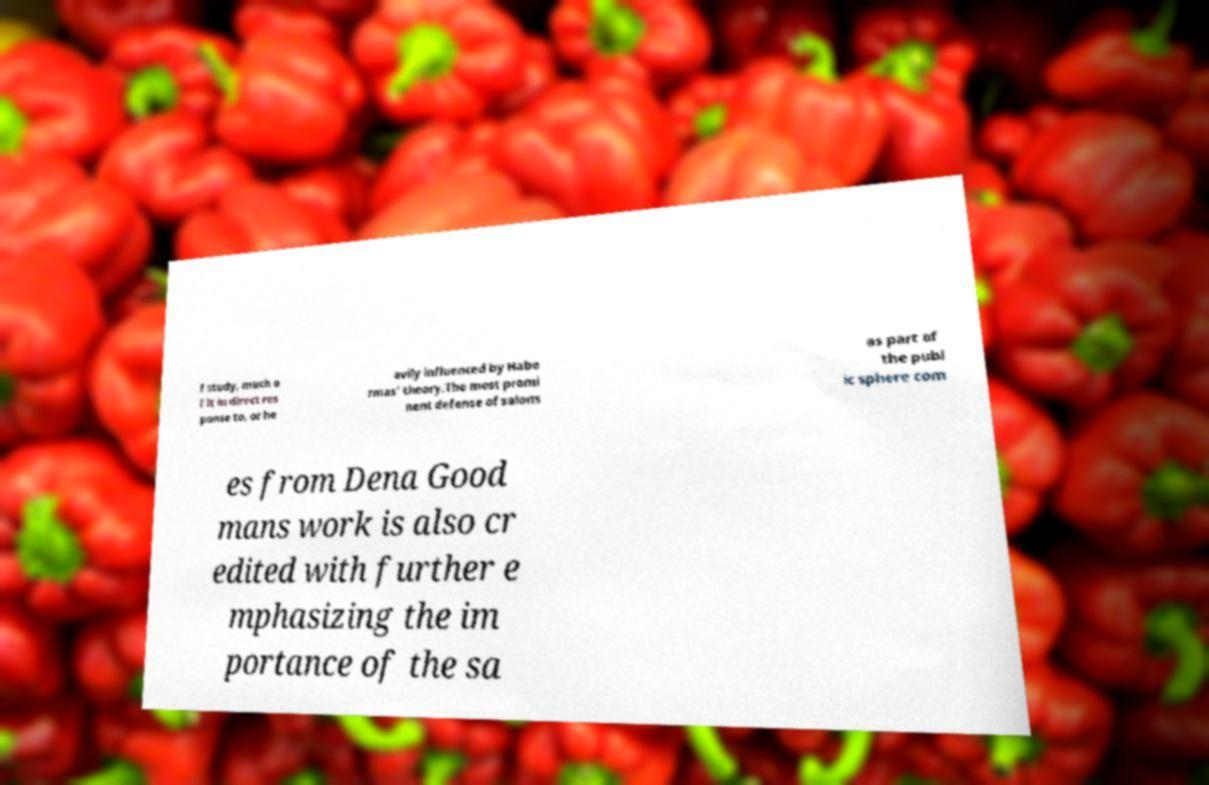Could you assist in decoding the text presented in this image and type it out clearly? f study, much o f it in direct res ponse to, or he avily influenced by Habe rmas' theory.The most promi nent defense of salons as part of the publ ic sphere com es from Dena Good mans work is also cr edited with further e mphasizing the im portance of the sa 